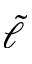Convert formula to latex. <formula><loc_0><loc_0><loc_500><loc_500>\tilde { \ell }</formula> 